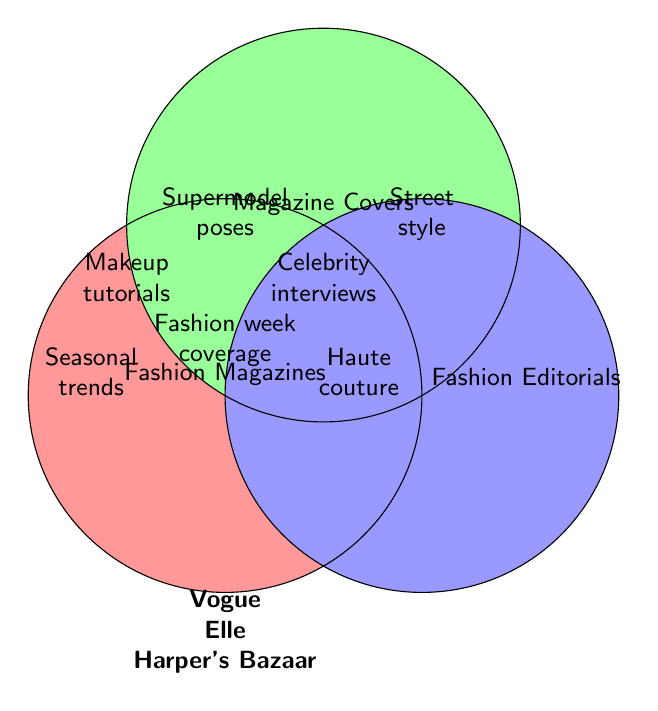What are the three main sections in the Venn diagram? There are three main labeled sections in the Venn diagram called "Fashion Magazines," "Magazine Covers," and "Fashion Editorials."
Answer: Fashion Magazines, Magazine Covers, Fashion Editorials Which topics are common to all three main sections? The Venn diagram shows that "Vogue," "Elle," and "Harper's Bazaar" are present in the intersection of all three main sections.
Answer: Vogue, Elle, Harper's Bazaar Which topic is covered by Fashion Magazines and Fashion Editorials but not by Magazine Covers? By checking the intersections, "Supermodel poses" is covered by Fashion Magazines and Fashion Editorials but not by Magazine Covers.
Answer: Supermodel poses What does the intersection of Fashion Magazines and Magazine Covers contain? The intersection of "Fashion Magazines" and "Magazine Covers" includes "Seasonal trends," "Makeup tutorials," and "Fashion week coverage."
Answer: Seasonal trends, Makeup tutorials, Fashion week coverage Which topics are exclusive to Magazine Covers? The Venn diagram shows that "Celebrity interviews" is the topic exclusive to Magazine Covers.
Answer: Celebrity interviews Which topics are common between Magazine Covers and Fashion Editorials but not included in Fashion Magazines? The intersection between "Magazine Covers" and "Fashion Editorials" that doesn't include "Fashion Magazines" is "Street style."
Answer: Street style How many topics does the intersection of Fashion Editorials and Magazine Covers contain? There are three topics in the intersection of Fashion Editorials and Magazine Covers: "Makeup tutorials," "Celebrity interviews," and "Fashion week coverage."
Answer: 3 Which topics are covered only under Fashion Editorials? By observing the Venn diagram, "Haute couture" and "Street style" are only under Fashion Editorials.
Answer: Haute couture, Street style 